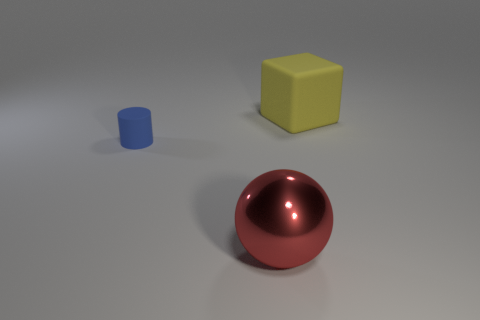Add 3 red metallic balls. How many objects exist? 6 Subtract all cylinders. How many objects are left? 2 Subtract 0 gray balls. How many objects are left? 3 Subtract all green things. Subtract all matte blocks. How many objects are left? 2 Add 3 red spheres. How many red spheres are left? 4 Add 1 tiny things. How many tiny things exist? 2 